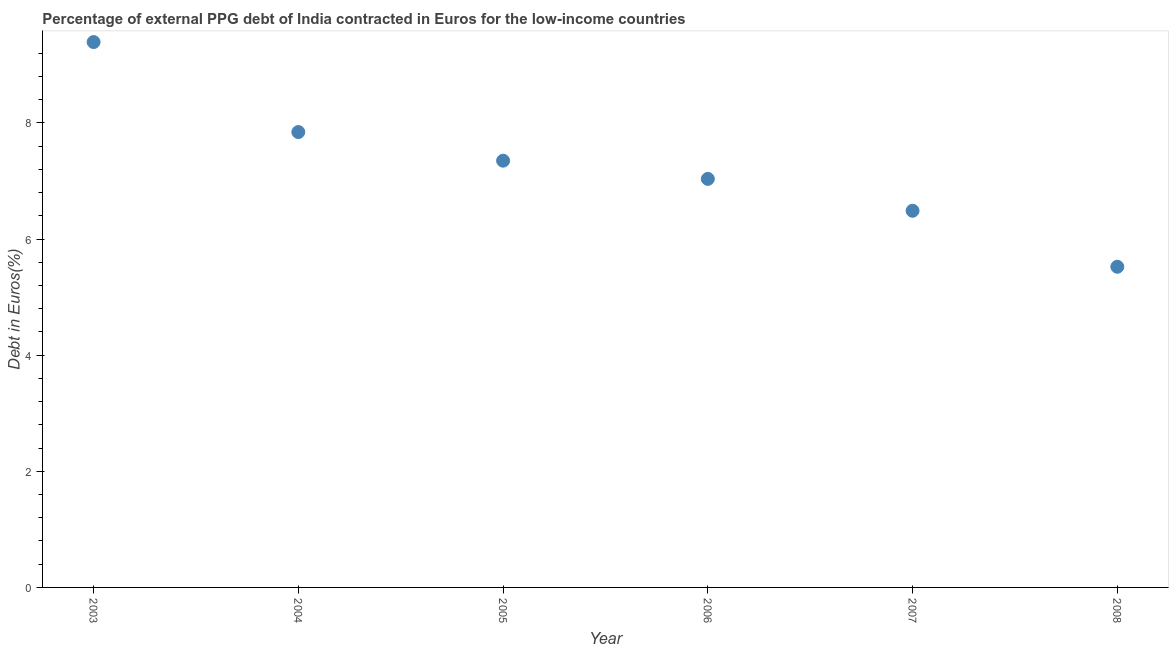What is the currency composition of ppg debt in 2007?
Your answer should be compact. 6.49. Across all years, what is the maximum currency composition of ppg debt?
Provide a succinct answer. 9.39. Across all years, what is the minimum currency composition of ppg debt?
Give a very brief answer. 5.52. In which year was the currency composition of ppg debt maximum?
Offer a terse response. 2003. What is the sum of the currency composition of ppg debt?
Offer a very short reply. 43.64. What is the difference between the currency composition of ppg debt in 2006 and 2007?
Offer a very short reply. 0.55. What is the average currency composition of ppg debt per year?
Ensure brevity in your answer.  7.27. What is the median currency composition of ppg debt?
Keep it short and to the point. 7.19. In how many years, is the currency composition of ppg debt greater than 4 %?
Your answer should be compact. 6. Do a majority of the years between 2005 and 2004 (inclusive) have currency composition of ppg debt greater than 7.6 %?
Offer a terse response. No. What is the ratio of the currency composition of ppg debt in 2004 to that in 2007?
Your answer should be compact. 1.21. Is the currency composition of ppg debt in 2003 less than that in 2004?
Make the answer very short. No. Is the difference between the currency composition of ppg debt in 2004 and 2005 greater than the difference between any two years?
Your answer should be very brief. No. What is the difference between the highest and the second highest currency composition of ppg debt?
Provide a succinct answer. 1.55. What is the difference between the highest and the lowest currency composition of ppg debt?
Your answer should be compact. 3.87. Does the currency composition of ppg debt monotonically increase over the years?
Keep it short and to the point. No. Are the values on the major ticks of Y-axis written in scientific E-notation?
Keep it short and to the point. No. Does the graph contain any zero values?
Provide a short and direct response. No. Does the graph contain grids?
Your answer should be very brief. No. What is the title of the graph?
Your answer should be compact. Percentage of external PPG debt of India contracted in Euros for the low-income countries. What is the label or title of the Y-axis?
Your answer should be compact. Debt in Euros(%). What is the Debt in Euros(%) in 2003?
Ensure brevity in your answer.  9.39. What is the Debt in Euros(%) in 2004?
Give a very brief answer. 7.84. What is the Debt in Euros(%) in 2005?
Your answer should be compact. 7.35. What is the Debt in Euros(%) in 2006?
Your response must be concise. 7.04. What is the Debt in Euros(%) in 2007?
Ensure brevity in your answer.  6.49. What is the Debt in Euros(%) in 2008?
Make the answer very short. 5.52. What is the difference between the Debt in Euros(%) in 2003 and 2004?
Your response must be concise. 1.55. What is the difference between the Debt in Euros(%) in 2003 and 2005?
Give a very brief answer. 2.04. What is the difference between the Debt in Euros(%) in 2003 and 2006?
Ensure brevity in your answer.  2.36. What is the difference between the Debt in Euros(%) in 2003 and 2007?
Keep it short and to the point. 2.91. What is the difference between the Debt in Euros(%) in 2003 and 2008?
Offer a terse response. 3.87. What is the difference between the Debt in Euros(%) in 2004 and 2005?
Make the answer very short. 0.49. What is the difference between the Debt in Euros(%) in 2004 and 2006?
Make the answer very short. 0.81. What is the difference between the Debt in Euros(%) in 2004 and 2007?
Give a very brief answer. 1.36. What is the difference between the Debt in Euros(%) in 2004 and 2008?
Ensure brevity in your answer.  2.32. What is the difference between the Debt in Euros(%) in 2005 and 2006?
Offer a very short reply. 0.31. What is the difference between the Debt in Euros(%) in 2005 and 2007?
Your response must be concise. 0.86. What is the difference between the Debt in Euros(%) in 2005 and 2008?
Offer a very short reply. 1.83. What is the difference between the Debt in Euros(%) in 2006 and 2007?
Give a very brief answer. 0.55. What is the difference between the Debt in Euros(%) in 2006 and 2008?
Your response must be concise. 1.51. What is the difference between the Debt in Euros(%) in 2007 and 2008?
Provide a short and direct response. 0.96. What is the ratio of the Debt in Euros(%) in 2003 to that in 2004?
Provide a short and direct response. 1.2. What is the ratio of the Debt in Euros(%) in 2003 to that in 2005?
Make the answer very short. 1.28. What is the ratio of the Debt in Euros(%) in 2003 to that in 2006?
Provide a short and direct response. 1.33. What is the ratio of the Debt in Euros(%) in 2003 to that in 2007?
Offer a very short reply. 1.45. What is the ratio of the Debt in Euros(%) in 2003 to that in 2008?
Make the answer very short. 1.7. What is the ratio of the Debt in Euros(%) in 2004 to that in 2005?
Your answer should be very brief. 1.07. What is the ratio of the Debt in Euros(%) in 2004 to that in 2006?
Give a very brief answer. 1.11. What is the ratio of the Debt in Euros(%) in 2004 to that in 2007?
Offer a very short reply. 1.21. What is the ratio of the Debt in Euros(%) in 2004 to that in 2008?
Offer a terse response. 1.42. What is the ratio of the Debt in Euros(%) in 2005 to that in 2006?
Offer a terse response. 1.04. What is the ratio of the Debt in Euros(%) in 2005 to that in 2007?
Give a very brief answer. 1.13. What is the ratio of the Debt in Euros(%) in 2005 to that in 2008?
Your answer should be very brief. 1.33. What is the ratio of the Debt in Euros(%) in 2006 to that in 2007?
Your answer should be compact. 1.08. What is the ratio of the Debt in Euros(%) in 2006 to that in 2008?
Your answer should be very brief. 1.27. What is the ratio of the Debt in Euros(%) in 2007 to that in 2008?
Your answer should be compact. 1.18. 